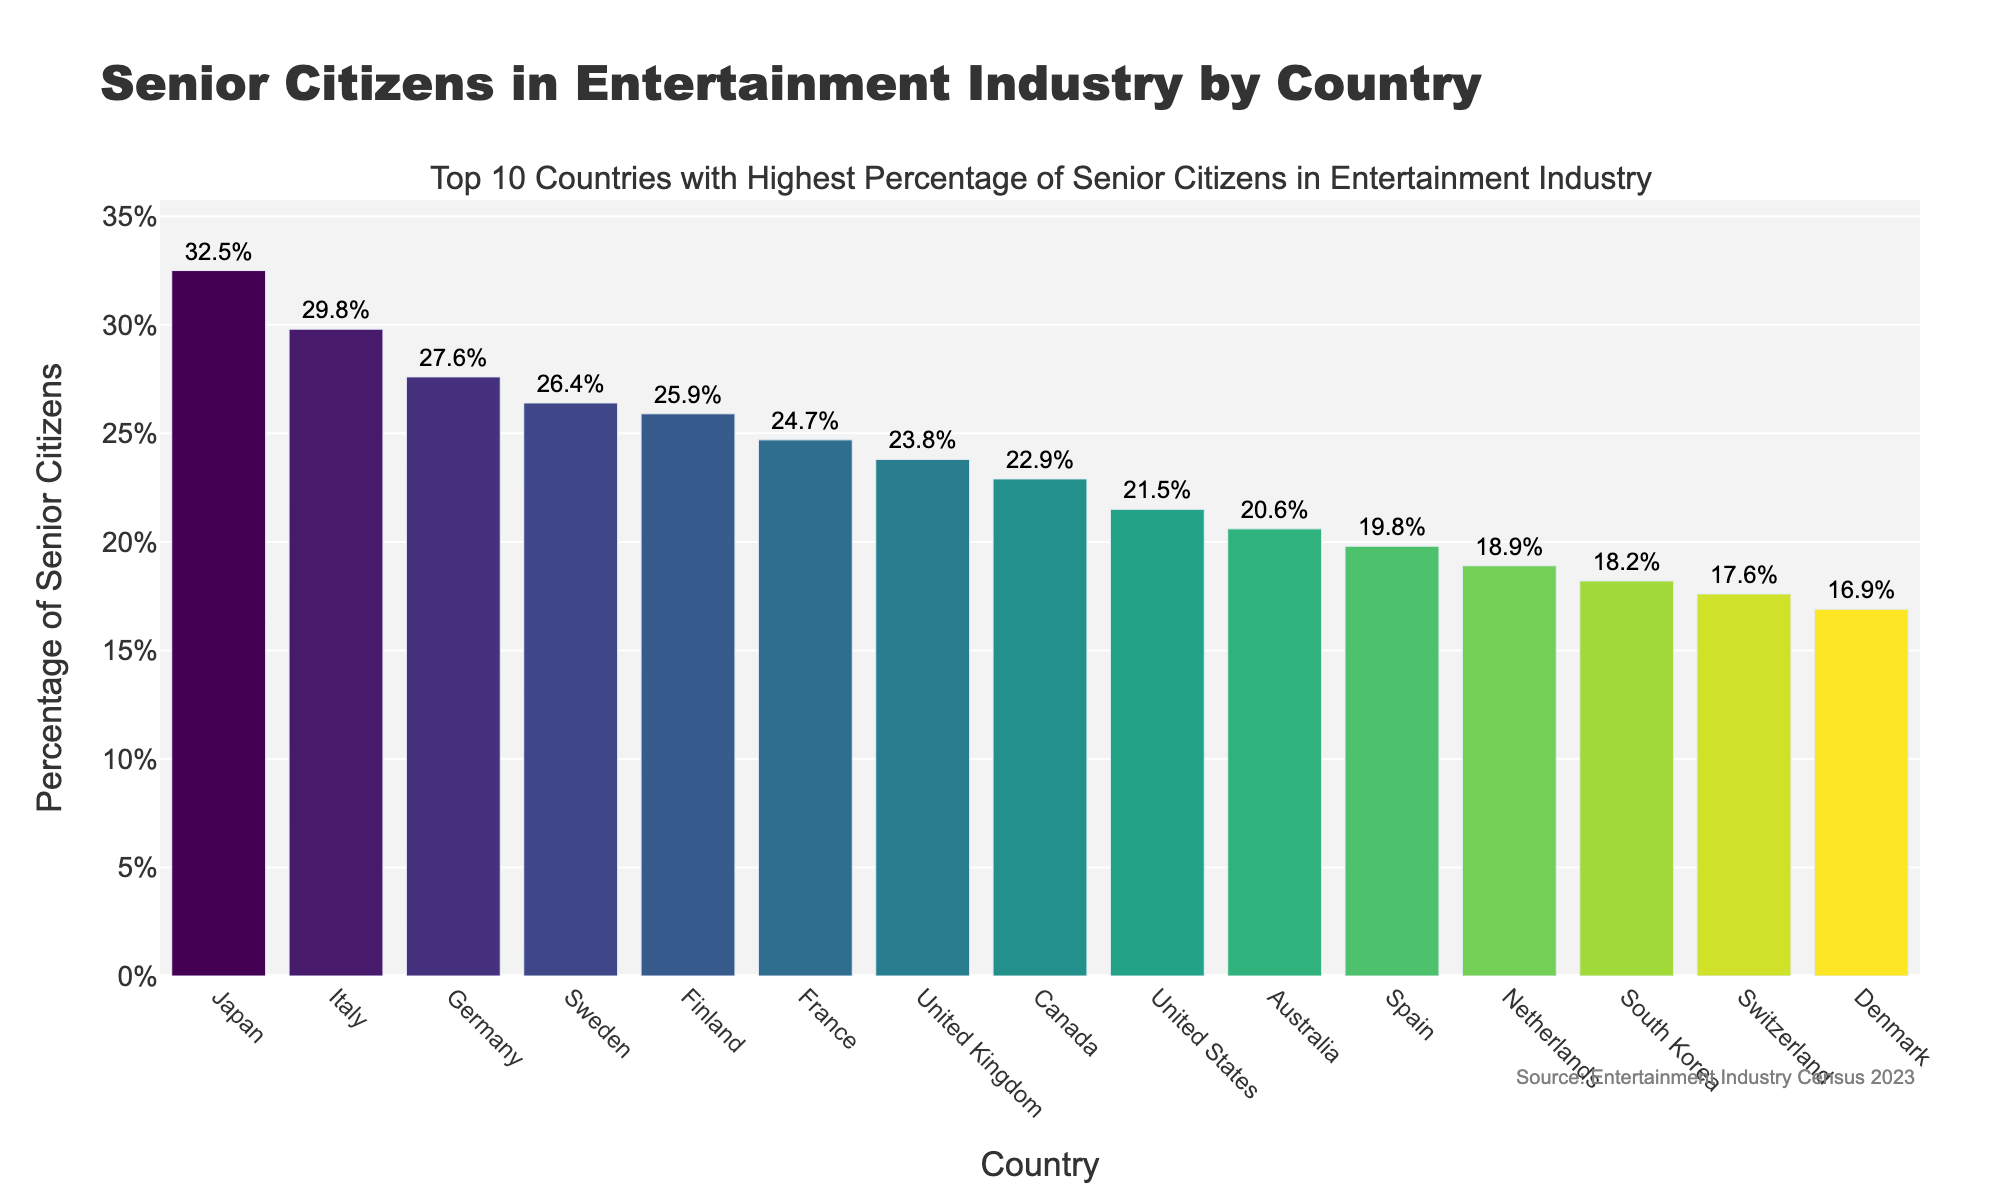What is the percentage of senior citizens in the entertainment industry in Japan? The figure shows a bar labeled "Japan," and above it, a percentage of 32.5% is displayed.
Answer: 32.5% Which country has a higher percentage of senior citizens in the entertainment industry: Canada or the United States? The bar for Canada shows a percentage of 22.9%, while the bar for the United States shows 21.5%. 22.9% is greater than 21.5%.
Answer: Canada What is the difference in the percentage of senior citizens between Germany and Sweden? The figure shows Germany at 27.6% and Sweden at 26.4%. The difference is 27.6% - 26.4% = 1.2%.
Answer: 1.2% What is the average percentage of senior citizens in the entertainment industry for the top three countries? The top three countries are Japan (32.5%), Italy (29.8%), and Germany (27.6%). The average is (32.5% + 29.8% + 27.6%) / 3 = 29.967%.
Answer: 29.97% Which country has the lowest percentage of senior citizens in the entertainment industry, and what is that percentage? The bar list indicates Denmark has the lowest percentage, at 16.9%.
Answer: Denmark, 16.9% How much higher is the percentage of senior citizens in the entertainment industry in France compared to South Korea? France has 24.7%, and South Korea has 18.2%. The difference is 24.7% - 18.2% = 6.5%.
Answer: 6.5% What is the total percentage of senior citizens in entertainment across Italy, Finland, and Australia? Adding the percentages for Italy (29.8%), Finland (25.9%), and Australia (20.6%) gives 29.8% + 25.9% + 20.6% = 76.3%.
Answer: 76.3% If the total bar height represents 100%, what portion does Canada represent? Canada's bar shows 22.9%. This indicates that Canada represents 22.9% of the total height if we consider the total as 100%.
Answer: 22.9% Which two adjacent countries on the x-axis have the closest percentages, and what are those percentages? Sweden (26.4%) and Finland (25.9%) are adjacent on the x-axis and have the closest percentages, with a difference of 0.5%.
Answer: Sweden (26.4%) and Finland (25.9%) What is the median percentage of senior citizens among all the countries listed? Listing the percentages in order: 16.9%, 17.6%, 18.2%, 18.9%, 19.8%, 20.6%, 21.5%, 22.9%, 23.8%, 24.7%, 25.9%, 26.4%, 27.6%, 29.8%, 32.5%. The median, being the middle value of this ordered list, is 22.9%.
Answer: 22.9% 